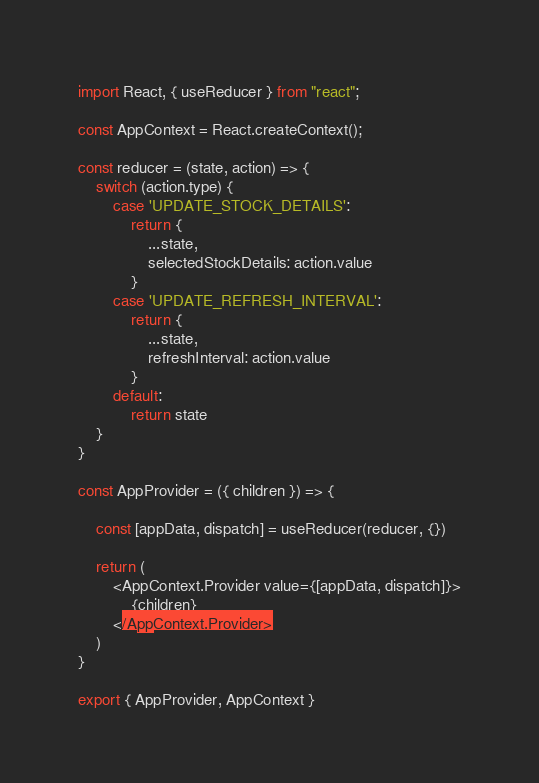<code> <loc_0><loc_0><loc_500><loc_500><_JavaScript_>import React, { useReducer } from "react";

const AppContext = React.createContext();

const reducer = (state, action) => {
    switch (action.type) {
        case 'UPDATE_STOCK_DETAILS':
            return {
                ...state,
                selectedStockDetails: action.value
            }
        case 'UPDATE_REFRESH_INTERVAL':
            return {
                ...state,
                refreshInterval: action.value
            }
        default:
            return state
    }
}

const AppProvider = ({ children }) => {

    const [appData, dispatch] = useReducer(reducer, {})

    return (
        <AppContext.Provider value={[appData, dispatch]}>
            {children}
        </AppContext.Provider>
    )
}

export { AppProvider, AppContext }</code> 